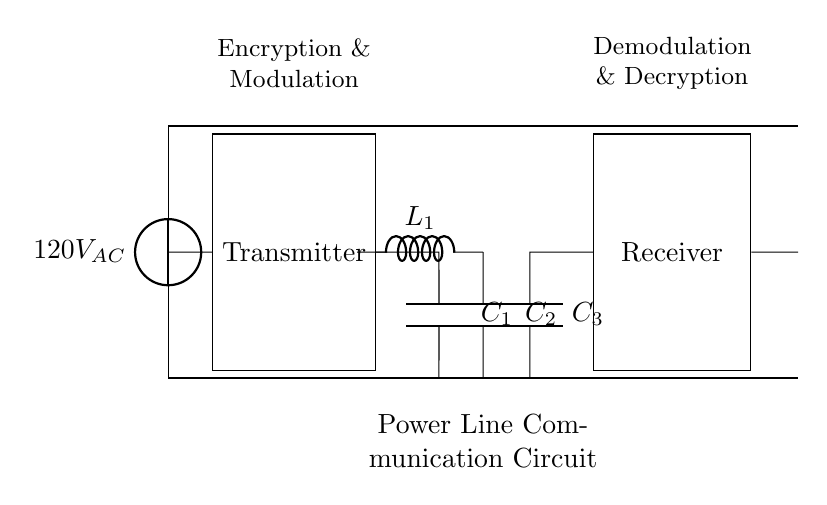What is the source voltage in this circuit? The source voltage is labeled as 120V AC, which indicates the potential difference provided by the AC voltage source at the beginning of the circuit.
Answer: 120V AC What components are used in the transmitter section? The transmitter section includes a rectangular box labeled "Transmitter" and a capacitor labeled C1. There are no additional components depicted in the transmitter section of the diagram.
Answer: Transmitter, C1 What type of component is L1 in the circuit? L1 is labeled in the circuit as an inductor, which is identified by its symbol in the schematic. An inductor is a passive component that stores energy in a magnetic field when electrical current flows through it.
Answer: Inductor What is the function of the capacitor C3? The role of capacitor C3 is primarily in the receiver section, where it is involved in demodulating the received signals and potentially filtering out unwanted frequencies as part of the signal recovery process.
Answer: Demodulation How many capacitors are present in the circuit? There are three capacitors depicted in the circuit, which are C1, C2, and C3. This is determined by counting the capacitor symbols in the schematic diagram.
Answer: 3 What is the primary purpose of this circuit? The main purpose of this circuit is power line communication, which involves transmitting encrypted data using existing electrical wiring as the transmission medium, indicated by the labeling in the diagram.
Answer: Communication What does the labeling above the transmitter indicate? The labeling above the transmitter indicates its functions, which are encryption and modulation. This implies that the transmitter both encrypts the data and modulates it for transmission over the power lines.
Answer: Encryption & Modulation 